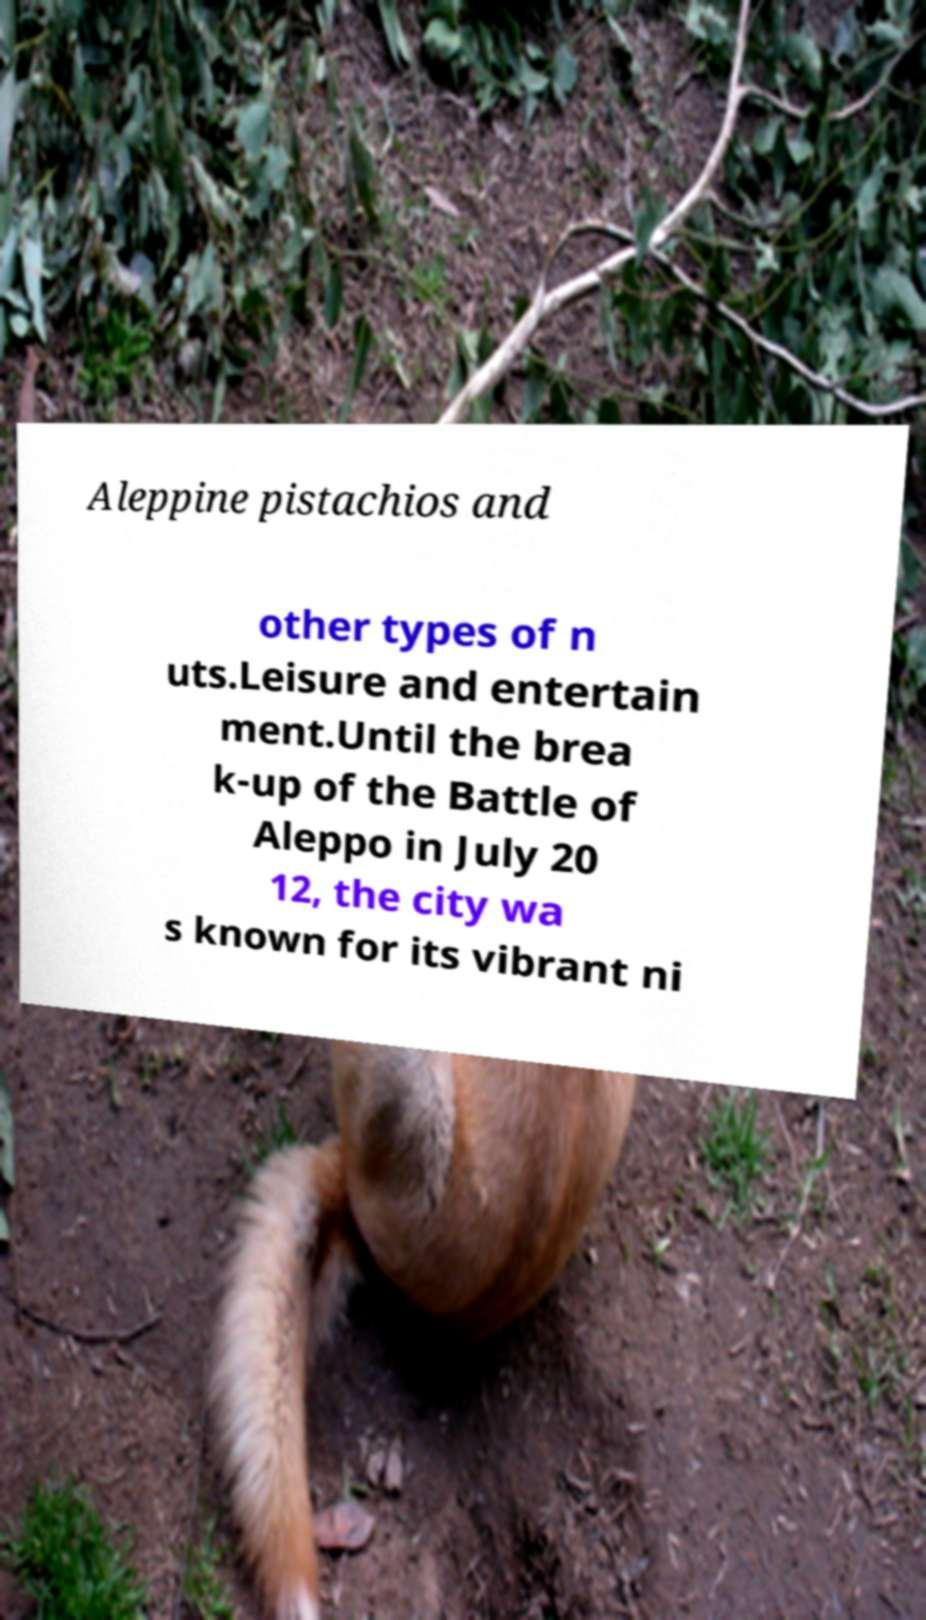For documentation purposes, I need the text within this image transcribed. Could you provide that? Aleppine pistachios and other types of n uts.Leisure and entertain ment.Until the brea k-up of the Battle of Aleppo in July 20 12, the city wa s known for its vibrant ni 